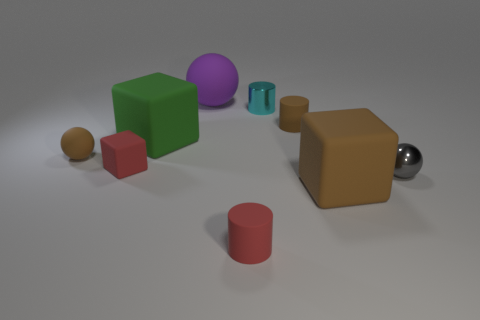What is the material of the tiny object that is the same color as the tiny matte ball?
Your answer should be compact. Rubber. Is the number of small red rubber objects that are right of the small red matte block less than the number of big purple rubber blocks?
Your answer should be compact. No. What color is the matte sphere on the left side of the red matte thing that is to the left of the big rubber object that is behind the small cyan cylinder?
Your answer should be compact. Brown. How many rubber things are either blocks or green cubes?
Your response must be concise. 3. Do the green block and the brown block have the same size?
Make the answer very short. Yes. Is the number of gray spheres left of the big purple matte sphere less than the number of big green blocks to the left of the large green thing?
Your response must be concise. No. Is there anything else that has the same size as the gray object?
Make the answer very short. Yes. How big is the cyan shiny object?
Make the answer very short. Small. What number of big things are metal cylinders or brown balls?
Give a very brief answer. 0. There is a brown rubber cylinder; is its size the same as the matte ball that is in front of the green block?
Your answer should be compact. Yes. 